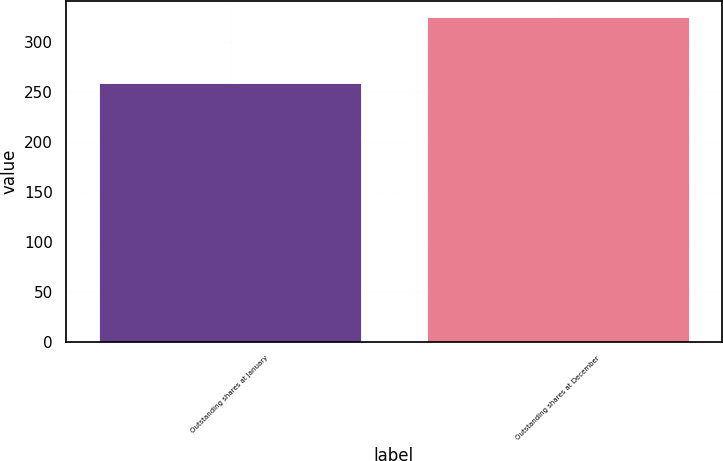Convert chart to OTSL. <chart><loc_0><loc_0><loc_500><loc_500><bar_chart><fcel>Outstanding shares at January<fcel>Outstanding shares at December<nl><fcel>259.1<fcel>325.13<nl></chart> 